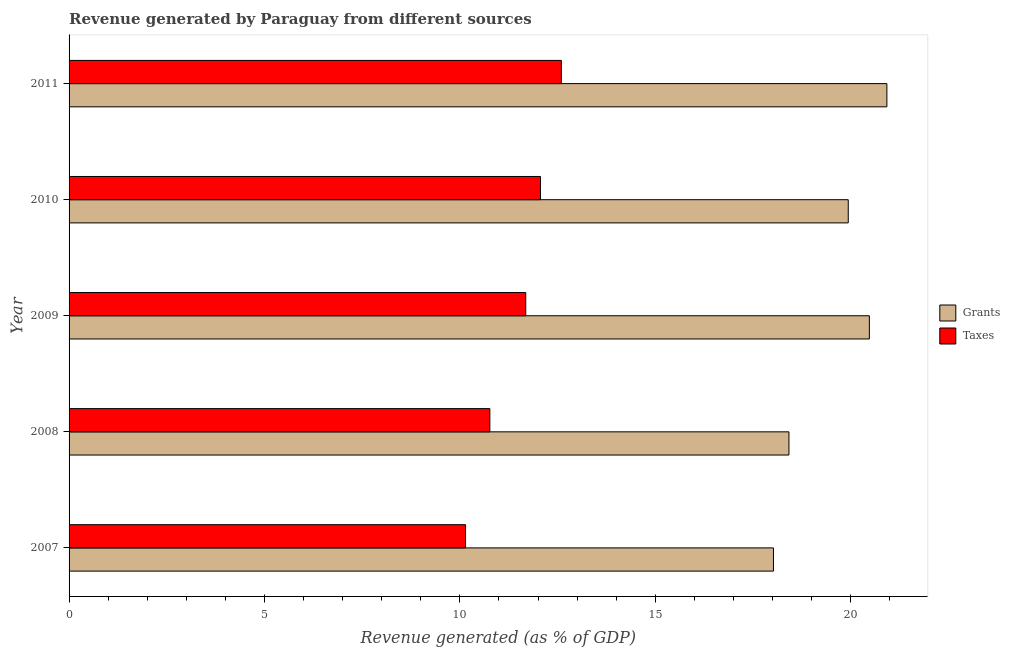How many different coloured bars are there?
Offer a very short reply. 2. How many groups of bars are there?
Your answer should be very brief. 5. Are the number of bars per tick equal to the number of legend labels?
Provide a succinct answer. Yes. Are the number of bars on each tick of the Y-axis equal?
Provide a short and direct response. Yes. How many bars are there on the 3rd tick from the top?
Your answer should be compact. 2. What is the label of the 4th group of bars from the top?
Your answer should be very brief. 2008. In how many cases, is the number of bars for a given year not equal to the number of legend labels?
Ensure brevity in your answer.  0. What is the revenue generated by grants in 2011?
Make the answer very short. 20.93. Across all years, what is the maximum revenue generated by grants?
Offer a very short reply. 20.93. Across all years, what is the minimum revenue generated by grants?
Your answer should be compact. 18.03. In which year was the revenue generated by taxes maximum?
Keep it short and to the point. 2011. In which year was the revenue generated by grants minimum?
Offer a very short reply. 2007. What is the total revenue generated by taxes in the graph?
Your response must be concise. 57.26. What is the difference between the revenue generated by taxes in 2009 and that in 2011?
Make the answer very short. -0.91. What is the difference between the revenue generated by taxes in 2009 and the revenue generated by grants in 2011?
Your answer should be very brief. -9.24. What is the average revenue generated by taxes per year?
Ensure brevity in your answer.  11.45. In the year 2008, what is the difference between the revenue generated by taxes and revenue generated by grants?
Your answer should be very brief. -7.65. What is the ratio of the revenue generated by grants in 2010 to that in 2011?
Make the answer very short. 0.95. What is the difference between the highest and the second highest revenue generated by taxes?
Your answer should be very brief. 0.53. What does the 2nd bar from the top in 2009 represents?
Provide a succinct answer. Grants. What does the 1st bar from the bottom in 2008 represents?
Provide a succinct answer. Grants. How many bars are there?
Your answer should be compact. 10. How many years are there in the graph?
Ensure brevity in your answer.  5. What is the difference between two consecutive major ticks on the X-axis?
Offer a terse response. 5. Where does the legend appear in the graph?
Provide a short and direct response. Center right. How many legend labels are there?
Offer a very short reply. 2. How are the legend labels stacked?
Provide a short and direct response. Vertical. What is the title of the graph?
Offer a terse response. Revenue generated by Paraguay from different sources. What is the label or title of the X-axis?
Your answer should be very brief. Revenue generated (as % of GDP). What is the label or title of the Y-axis?
Your answer should be very brief. Year. What is the Revenue generated (as % of GDP) of Grants in 2007?
Your answer should be very brief. 18.03. What is the Revenue generated (as % of GDP) in Taxes in 2007?
Provide a short and direct response. 10.15. What is the Revenue generated (as % of GDP) of Grants in 2008?
Ensure brevity in your answer.  18.42. What is the Revenue generated (as % of GDP) in Taxes in 2008?
Offer a very short reply. 10.77. What is the Revenue generated (as % of GDP) of Grants in 2009?
Keep it short and to the point. 20.48. What is the Revenue generated (as % of GDP) of Taxes in 2009?
Offer a terse response. 11.69. What is the Revenue generated (as % of GDP) of Grants in 2010?
Give a very brief answer. 19.94. What is the Revenue generated (as % of GDP) in Taxes in 2010?
Your response must be concise. 12.06. What is the Revenue generated (as % of GDP) in Grants in 2011?
Ensure brevity in your answer.  20.93. What is the Revenue generated (as % of GDP) of Taxes in 2011?
Provide a succinct answer. 12.6. Across all years, what is the maximum Revenue generated (as % of GDP) of Grants?
Make the answer very short. 20.93. Across all years, what is the maximum Revenue generated (as % of GDP) of Taxes?
Offer a very short reply. 12.6. Across all years, what is the minimum Revenue generated (as % of GDP) in Grants?
Your answer should be compact. 18.03. Across all years, what is the minimum Revenue generated (as % of GDP) of Taxes?
Your answer should be compact. 10.15. What is the total Revenue generated (as % of GDP) of Grants in the graph?
Offer a very short reply. 97.8. What is the total Revenue generated (as % of GDP) in Taxes in the graph?
Your answer should be very brief. 57.26. What is the difference between the Revenue generated (as % of GDP) of Grants in 2007 and that in 2008?
Your response must be concise. -0.4. What is the difference between the Revenue generated (as % of GDP) of Taxes in 2007 and that in 2008?
Ensure brevity in your answer.  -0.62. What is the difference between the Revenue generated (as % of GDP) in Grants in 2007 and that in 2009?
Offer a very short reply. -2.45. What is the difference between the Revenue generated (as % of GDP) in Taxes in 2007 and that in 2009?
Your answer should be compact. -1.54. What is the difference between the Revenue generated (as % of GDP) of Grants in 2007 and that in 2010?
Make the answer very short. -1.91. What is the difference between the Revenue generated (as % of GDP) in Taxes in 2007 and that in 2010?
Your answer should be very brief. -1.92. What is the difference between the Revenue generated (as % of GDP) in Grants in 2007 and that in 2011?
Offer a terse response. -2.9. What is the difference between the Revenue generated (as % of GDP) of Taxes in 2007 and that in 2011?
Your answer should be very brief. -2.45. What is the difference between the Revenue generated (as % of GDP) of Grants in 2008 and that in 2009?
Provide a succinct answer. -2.06. What is the difference between the Revenue generated (as % of GDP) of Taxes in 2008 and that in 2009?
Provide a short and direct response. -0.92. What is the difference between the Revenue generated (as % of GDP) of Grants in 2008 and that in 2010?
Keep it short and to the point. -1.52. What is the difference between the Revenue generated (as % of GDP) of Taxes in 2008 and that in 2010?
Keep it short and to the point. -1.3. What is the difference between the Revenue generated (as % of GDP) of Grants in 2008 and that in 2011?
Provide a short and direct response. -2.51. What is the difference between the Revenue generated (as % of GDP) in Taxes in 2008 and that in 2011?
Make the answer very short. -1.83. What is the difference between the Revenue generated (as % of GDP) of Grants in 2009 and that in 2010?
Offer a terse response. 0.54. What is the difference between the Revenue generated (as % of GDP) of Taxes in 2009 and that in 2010?
Offer a terse response. -0.38. What is the difference between the Revenue generated (as % of GDP) of Grants in 2009 and that in 2011?
Provide a succinct answer. -0.45. What is the difference between the Revenue generated (as % of GDP) of Taxes in 2009 and that in 2011?
Make the answer very short. -0.91. What is the difference between the Revenue generated (as % of GDP) of Grants in 2010 and that in 2011?
Make the answer very short. -0.99. What is the difference between the Revenue generated (as % of GDP) of Taxes in 2010 and that in 2011?
Your response must be concise. -0.53. What is the difference between the Revenue generated (as % of GDP) in Grants in 2007 and the Revenue generated (as % of GDP) in Taxes in 2008?
Ensure brevity in your answer.  7.26. What is the difference between the Revenue generated (as % of GDP) of Grants in 2007 and the Revenue generated (as % of GDP) of Taxes in 2009?
Make the answer very short. 6.34. What is the difference between the Revenue generated (as % of GDP) in Grants in 2007 and the Revenue generated (as % of GDP) in Taxes in 2010?
Provide a succinct answer. 5.96. What is the difference between the Revenue generated (as % of GDP) of Grants in 2007 and the Revenue generated (as % of GDP) of Taxes in 2011?
Give a very brief answer. 5.43. What is the difference between the Revenue generated (as % of GDP) of Grants in 2008 and the Revenue generated (as % of GDP) of Taxes in 2009?
Keep it short and to the point. 6.74. What is the difference between the Revenue generated (as % of GDP) of Grants in 2008 and the Revenue generated (as % of GDP) of Taxes in 2010?
Give a very brief answer. 6.36. What is the difference between the Revenue generated (as % of GDP) of Grants in 2008 and the Revenue generated (as % of GDP) of Taxes in 2011?
Provide a succinct answer. 5.82. What is the difference between the Revenue generated (as % of GDP) in Grants in 2009 and the Revenue generated (as % of GDP) in Taxes in 2010?
Keep it short and to the point. 8.42. What is the difference between the Revenue generated (as % of GDP) in Grants in 2009 and the Revenue generated (as % of GDP) in Taxes in 2011?
Give a very brief answer. 7.88. What is the difference between the Revenue generated (as % of GDP) of Grants in 2010 and the Revenue generated (as % of GDP) of Taxes in 2011?
Your response must be concise. 7.34. What is the average Revenue generated (as % of GDP) in Grants per year?
Ensure brevity in your answer.  19.56. What is the average Revenue generated (as % of GDP) in Taxes per year?
Give a very brief answer. 11.45. In the year 2007, what is the difference between the Revenue generated (as % of GDP) of Grants and Revenue generated (as % of GDP) of Taxes?
Your answer should be very brief. 7.88. In the year 2008, what is the difference between the Revenue generated (as % of GDP) in Grants and Revenue generated (as % of GDP) in Taxes?
Your answer should be compact. 7.65. In the year 2009, what is the difference between the Revenue generated (as % of GDP) of Grants and Revenue generated (as % of GDP) of Taxes?
Give a very brief answer. 8.79. In the year 2010, what is the difference between the Revenue generated (as % of GDP) of Grants and Revenue generated (as % of GDP) of Taxes?
Keep it short and to the point. 7.88. In the year 2011, what is the difference between the Revenue generated (as % of GDP) in Grants and Revenue generated (as % of GDP) in Taxes?
Ensure brevity in your answer.  8.33. What is the ratio of the Revenue generated (as % of GDP) of Grants in 2007 to that in 2008?
Offer a very short reply. 0.98. What is the ratio of the Revenue generated (as % of GDP) in Taxes in 2007 to that in 2008?
Your response must be concise. 0.94. What is the ratio of the Revenue generated (as % of GDP) of Grants in 2007 to that in 2009?
Your response must be concise. 0.88. What is the ratio of the Revenue generated (as % of GDP) of Taxes in 2007 to that in 2009?
Ensure brevity in your answer.  0.87. What is the ratio of the Revenue generated (as % of GDP) in Grants in 2007 to that in 2010?
Offer a very short reply. 0.9. What is the ratio of the Revenue generated (as % of GDP) of Taxes in 2007 to that in 2010?
Provide a short and direct response. 0.84. What is the ratio of the Revenue generated (as % of GDP) of Grants in 2007 to that in 2011?
Keep it short and to the point. 0.86. What is the ratio of the Revenue generated (as % of GDP) of Taxes in 2007 to that in 2011?
Offer a very short reply. 0.81. What is the ratio of the Revenue generated (as % of GDP) in Grants in 2008 to that in 2009?
Provide a succinct answer. 0.9. What is the ratio of the Revenue generated (as % of GDP) in Taxes in 2008 to that in 2009?
Provide a short and direct response. 0.92. What is the ratio of the Revenue generated (as % of GDP) of Grants in 2008 to that in 2010?
Your response must be concise. 0.92. What is the ratio of the Revenue generated (as % of GDP) of Taxes in 2008 to that in 2010?
Provide a succinct answer. 0.89. What is the ratio of the Revenue generated (as % of GDP) of Grants in 2008 to that in 2011?
Your answer should be very brief. 0.88. What is the ratio of the Revenue generated (as % of GDP) in Taxes in 2008 to that in 2011?
Provide a short and direct response. 0.85. What is the ratio of the Revenue generated (as % of GDP) of Grants in 2009 to that in 2010?
Your response must be concise. 1.03. What is the ratio of the Revenue generated (as % of GDP) in Taxes in 2009 to that in 2010?
Offer a very short reply. 0.97. What is the ratio of the Revenue generated (as % of GDP) in Grants in 2009 to that in 2011?
Your answer should be very brief. 0.98. What is the ratio of the Revenue generated (as % of GDP) in Taxes in 2009 to that in 2011?
Your response must be concise. 0.93. What is the ratio of the Revenue generated (as % of GDP) of Grants in 2010 to that in 2011?
Your answer should be compact. 0.95. What is the ratio of the Revenue generated (as % of GDP) in Taxes in 2010 to that in 2011?
Provide a short and direct response. 0.96. What is the difference between the highest and the second highest Revenue generated (as % of GDP) in Grants?
Offer a very short reply. 0.45. What is the difference between the highest and the second highest Revenue generated (as % of GDP) of Taxes?
Offer a very short reply. 0.53. What is the difference between the highest and the lowest Revenue generated (as % of GDP) of Grants?
Offer a very short reply. 2.9. What is the difference between the highest and the lowest Revenue generated (as % of GDP) of Taxes?
Offer a terse response. 2.45. 